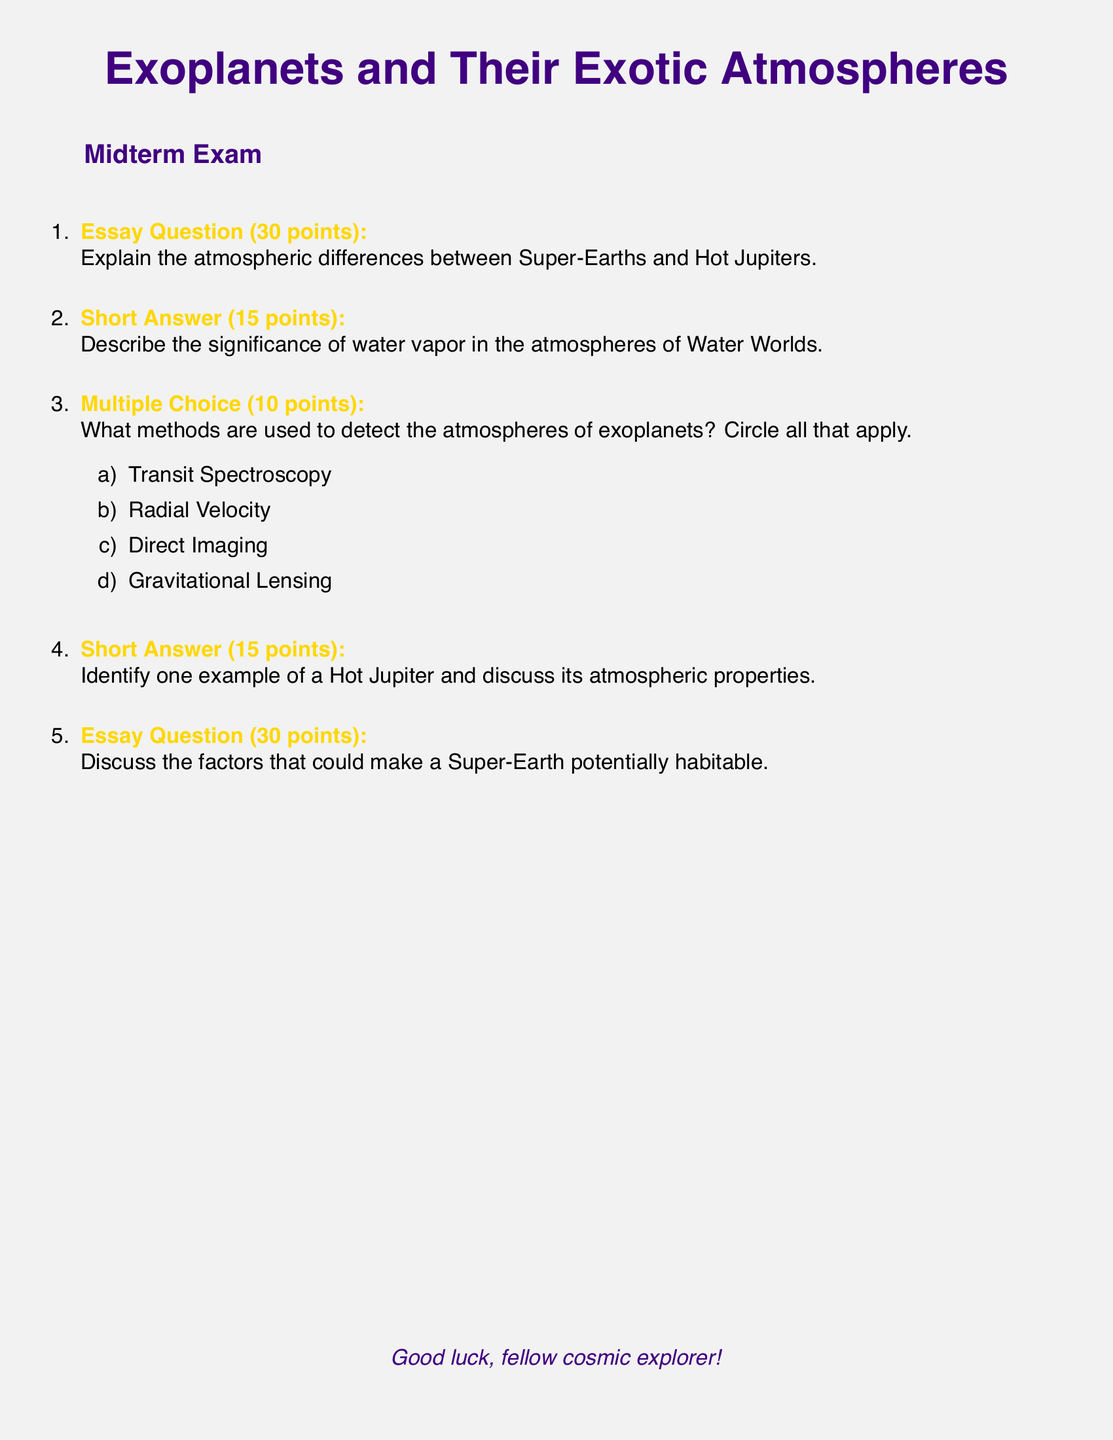What is the main topic of the document? The document is focused on exoplanets and their exotic atmospheres, specifically discussing Super-Earths, Hot Jupiters, and Water Worlds.
Answer: Exoplanets and Their Exotic Atmospheres How many points is the essay question worth? The essay question in the document is assigned a total of 30 points.
Answer: 30 points Which exoplanet type is mentioned in the context of atmospheric differences? The document mentions Super-Earths and Hot Jupiters while discussing atmospheric differences.
Answer: Super-Earths and Hot Jupiters What is one method used to detect exoplanet atmospheres? Transit Spectroscopy is one of the methods listed in the document for detecting exoplanet atmospheres.
Answer: Transit Spectroscopy How many short answer questions are included in the exam? The document contains two short answer questions in the midterm exam.
Answer: 2 What could make a Super-Earth potentially habitable? The document prompts discussion on factors that could make a Super-Earth potentially habitable.
Answer: Potentially habitable factors What is the total number of questions in the document? There are a total of five questions listed in the midterm exam.
Answer: 5 Which celestial bodies are referred to as Water Worlds in the document? The term Water Worlds in the document refers to exoplanets that have significant amounts of water vapor in their atmospheres.
Answer: Water Worlds What color is used for the titles of the questions in the document? The titles of the questions are colored stargold in the document.
Answer: Stargold 